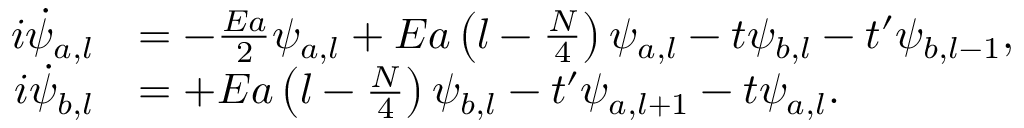<formula> <loc_0><loc_0><loc_500><loc_500>\begin{array} { r l } { i \dot { \psi } _ { a , l } } & { = - \frac { E a } { 2 } \psi _ { a , l } + E a \left ( l - \frac { N } { 4 } \right ) \psi _ { a , l } - t \psi _ { b , l } - t ^ { \prime } \psi _ { b , l - 1 } , } \\ { i \dot { \psi } _ { b , l } } & { = + E a \left ( l - \frac { N } { 4 } \right ) \psi _ { b , l } - t ^ { \prime } \psi _ { a , l + 1 } - t \psi _ { a , l } . } \end{array}</formula> 